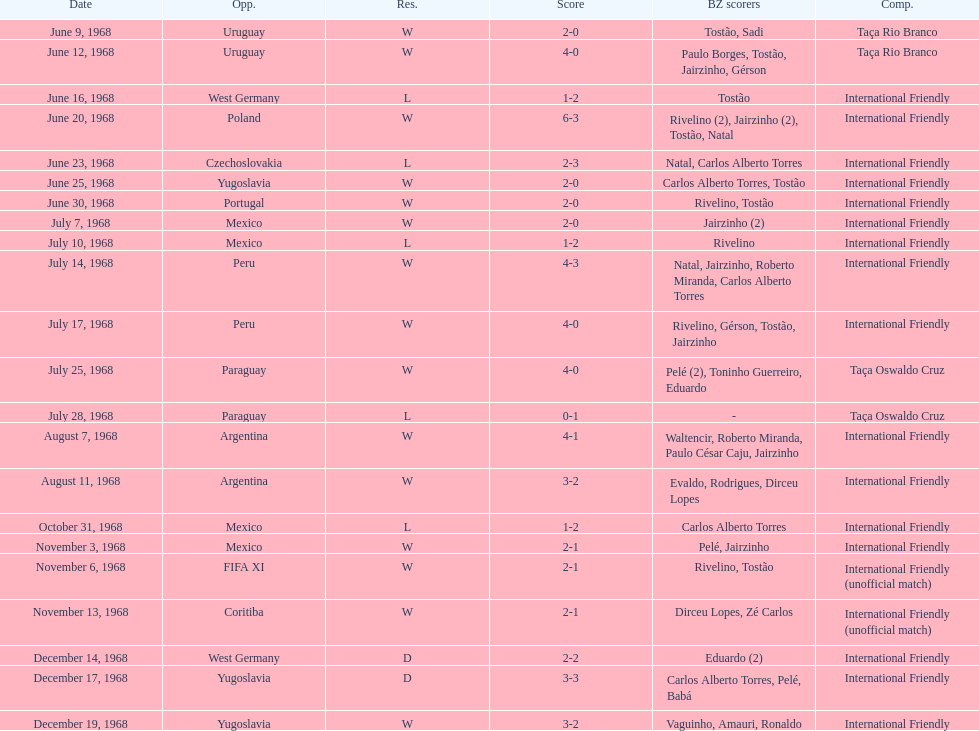Number of losses 5. 